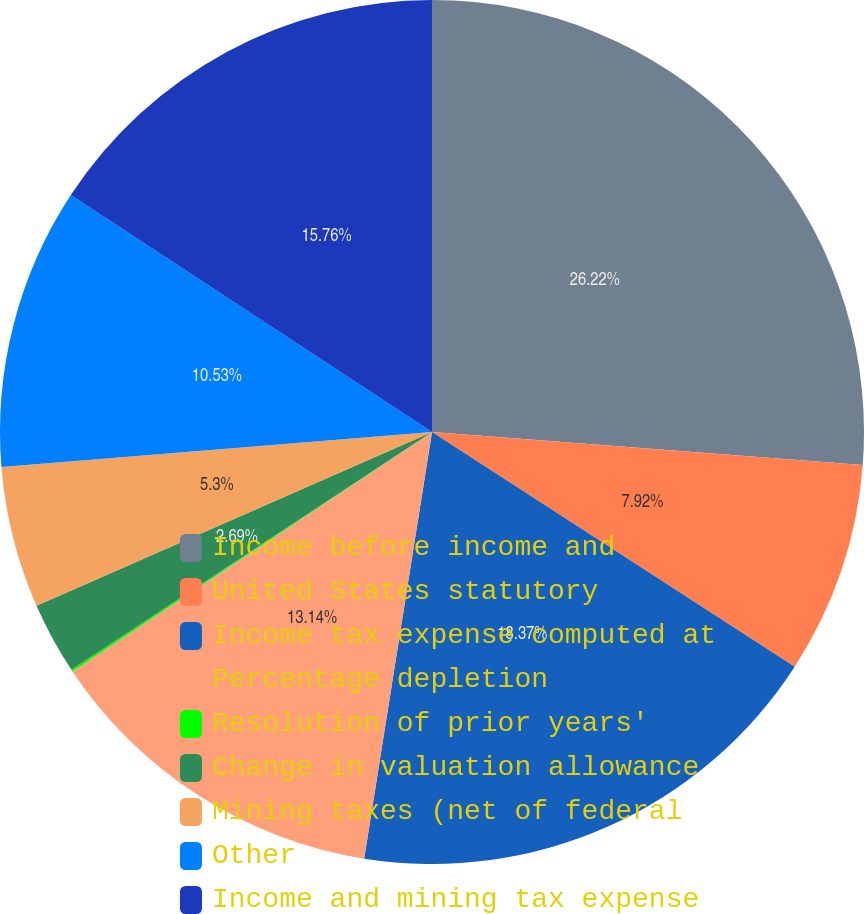Convert chart to OTSL. <chart><loc_0><loc_0><loc_500><loc_500><pie_chart><fcel>Income before income and<fcel>United States statutory<fcel>Income tax expense computed at<fcel>Percentage depletion<fcel>Resolution of prior years'<fcel>Change in valuation allowance<fcel>Mining taxes (net of federal<fcel>Other<fcel>Income and mining tax expense<nl><fcel>26.22%<fcel>7.92%<fcel>18.37%<fcel>13.14%<fcel>0.07%<fcel>2.69%<fcel>5.3%<fcel>10.53%<fcel>15.76%<nl></chart> 